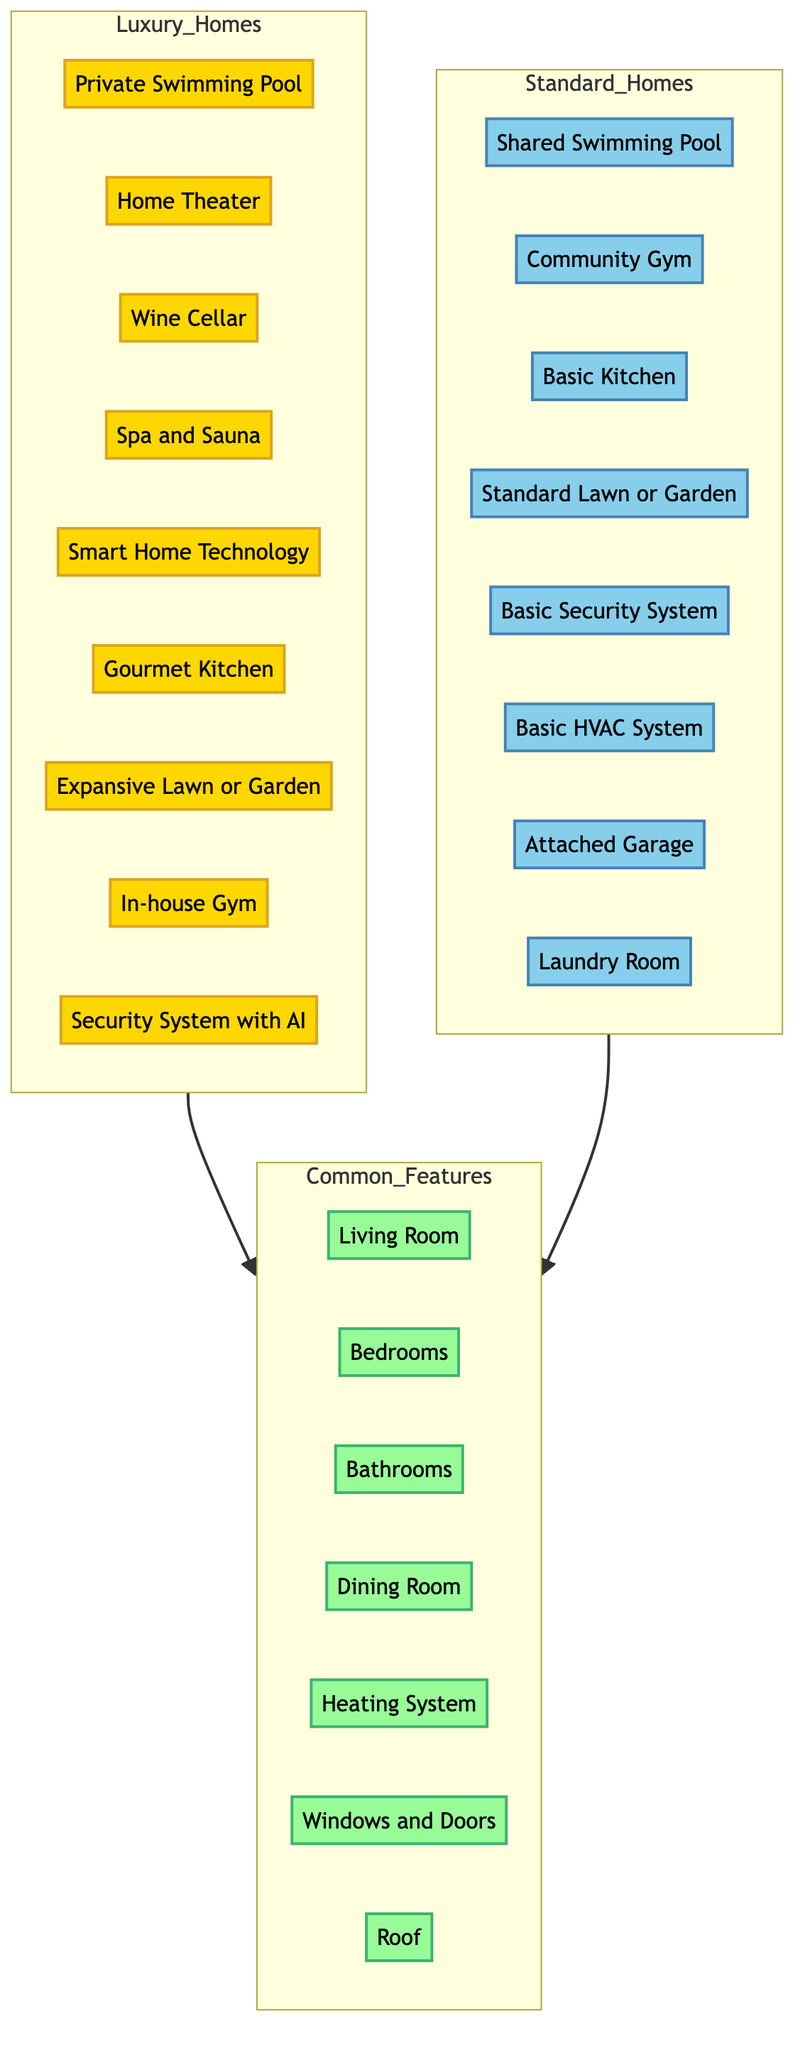What is a feature exclusive to luxury homes? In the Luxury_Homes subgraph, features such as the Private Swimming Pool and Home Theater are present but not found in the Standard_Homes subgraph. Picking any of these features illustrates exclusivity.
Answer: Private Swimming Pool How many common features are there between luxury homes and standard homes? The Common_Features subgraph lists 7 features that are shared between both luxury and standard homes, indicating they have a commonality in design and functionality.
Answer: 7 Which security feature is found in luxury homes but not in standard homes? The Luxury_Homes subgraph includes a Security System with AI, which is absent in the Standard_Homes subgraph, highlighting a significant difference in security offerings.
Answer: Security System with AI What type of kitchen is included in standard homes? The Standard_Homes subgraph specifies a Basic Kitchen, differentiating it from the more advanced options available in luxury homes, emphasizing simplicity versus sophistication.
Answer: Basic Kitchen How many amenities are exclusive to standard homes? Examining the Standard_Homes subgraph shows that all listed features, such as the Shared Swimming Pool and Community Gym, are not found among the luxury offerings, showcasing amenities unique to standard homes.
Answer: 8 What do luxury homes offer that is not typically found in standard homes? Through comparison, luxury homes feature amenities like a Wine Cellar or Spa and Sauna that don't appear in standard homes, indicating higher levels of luxury and personalization.
Answer: Wine Cellar Which common feature is present in both luxury and standard homes? Features such as Bedrooms and Bathrooms appear in the Common_Features section, confirming they are standard elements across both types of homes, revealing their foundational roles in residence design.
Answer: Bedrooms What is the total count of unique amenities in luxury homes? Counting features solely listed under Luxury_Homes gives us 9 unique amenities, illustrating the extensive offerings available to upscale homeowners compared to standard offerings.
Answer: 9 Which amenity in standard homes relates to parking? The Attached Garage is the feature within the Standard_Homes subgraph that addresses parking needs, clearly defining a practical consideration for homeowners seeking functional attributes.
Answer: Attached Garage 